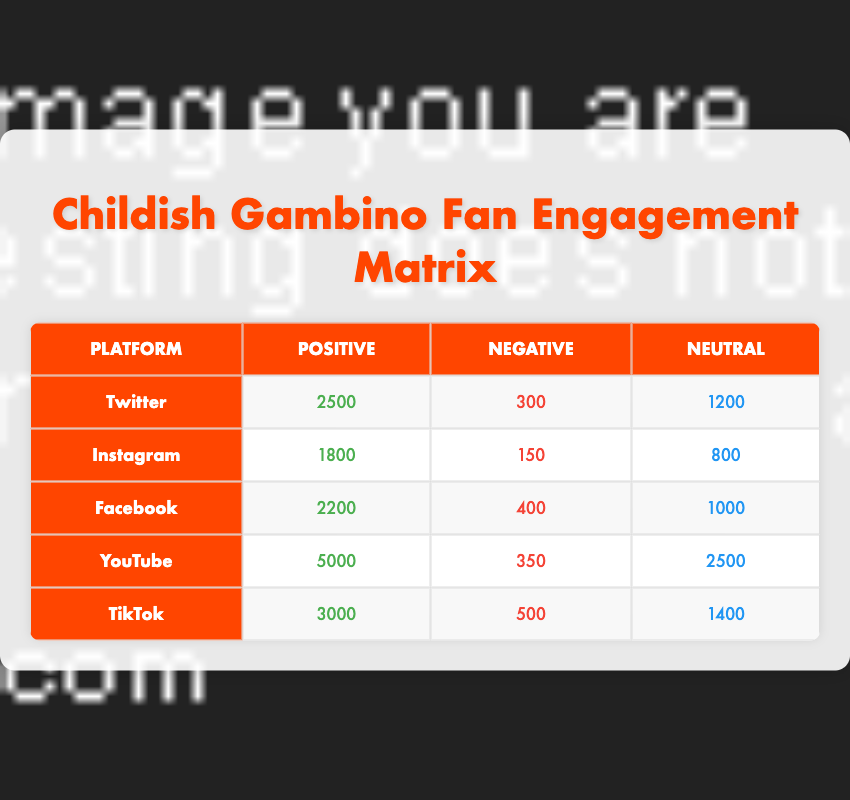What is the total positive engagement across all platforms? To find the total positive engagement, we need to add the positive engagement values from each platform: 2500 (Twitter) + 1800 (Instagram) + 2200 (Facebook) + 5000 (YouTube) + 3000 (TikTok) = 14500.
Answer: 14500 Which platform has the highest number of negative engagements? Checking the negative engagement values from each platform: 300 (Twitter), 150 (Instagram), 400 (Facebook), 350 (YouTube), and 500 (TikTok). The highest is 500 from TikTok.
Answer: TikTok Is the neutral engagement on YouTube greater than that on Instagram? The neutral engagement on YouTube is 2500, while on Instagram it is 800. Since 2500 is greater than 800, the statement is true.
Answer: Yes What is the average negative engagement across all platforms? To find the average, we first sum the negative engagement values: 300 (Twitter) + 150 (Instagram) + 400 (Facebook) + 350 (YouTube) + 500 (TikTok) = 1700. Then, we divide by the number of platforms, which is 5, yielding 1700/5 = 340.
Answer: 340 Which platform has the highest positive engagement? The positive engagement values are: 2500 (Twitter), 1800 (Instagram), 2200 (Facebook), 5000 (YouTube), and 3000 (TikTok). The highest is 5000, found on YouTube.
Answer: YouTube What is the total neutral engagement across all platforms? Adding the neutral engagement values gives: 1200 (Twitter) + 800 (Instagram) + 1000 (Facebook) + 2500 (YouTube) + 1400 (TikTok) = 4900.
Answer: 4900 Is the total engagement on Facebook higher than that on Instagram? For Facebook, the total engagement is 2200 (positive) + 400 (negative) + 1000 (neutral) = 3600. For Instagram, it is 1800 + 150 + 800 = 2750. Since 3600 is greater than 2750, the statement is true.
Answer: Yes What is the difference in positive engagement between TikTok and Twitter? The positive engagement for TikTok is 3000 and for Twitter is 2500. The difference is 3000 - 2500 = 500.
Answer: 500 Which platform has a higher ratio of negative to positive engagement, Instagram or Facebook? For Instagram, the ratio is 150 (negative) / 1800 (positive) = 0.0833. For Facebook, it's 400 / 2200 = 0.1818. Since 0.1818 (Facebook) is greater than 0.0833 (Instagram), Facebook has the higher ratio.
Answer: Facebook 